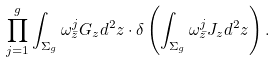Convert formula to latex. <formula><loc_0><loc_0><loc_500><loc_500>\prod _ { j = 1 } ^ { g } \int _ { \Sigma _ { g } } \omega ^ { j } _ { \bar { z } } G _ { z } d ^ { 2 } z \cdot \delta \left ( \int _ { \Sigma _ { g } } \omega ^ { j } _ { \bar { z } } J _ { z } d ^ { 2 } z \right ) .</formula> 